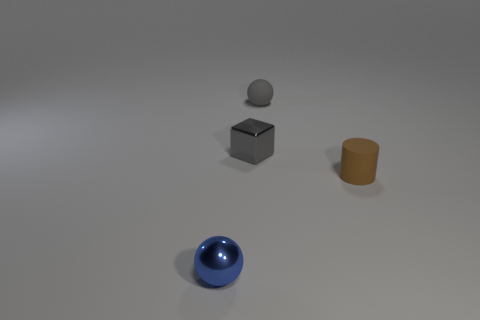What number of other things are there of the same color as the metallic block? There is one other object sharing the same color as the metallic block, which is the small sphere located above it. 